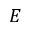Convert formula to latex. <formula><loc_0><loc_0><loc_500><loc_500>E</formula> 